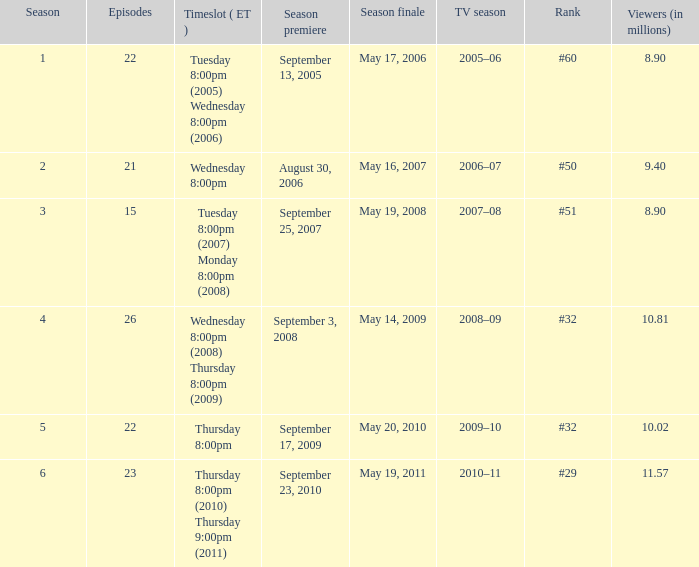How many seasons was the rank equal to #50? 1.0. 